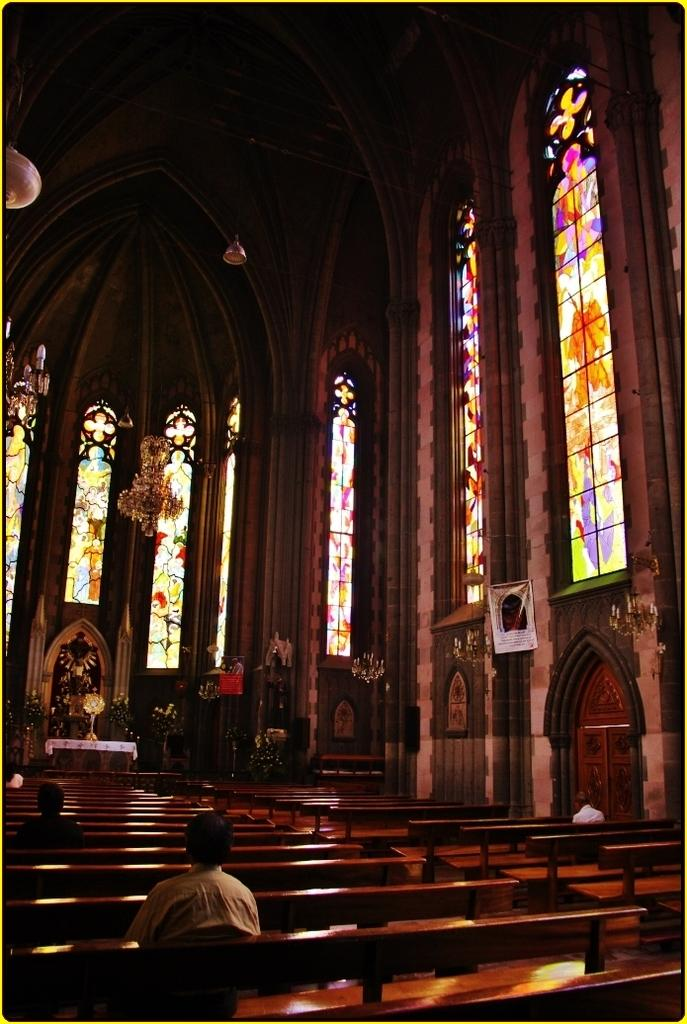What are the people in the image doing? The people in the image are sitting on benches. What other object can be seen in the image besides the people? There is a statue in the image. What type of lighting is present in the image? There are lights on the ceiling in the image. What can be seen on the windows in the image? There are designer glasses on the windows in the image. What type of sheet is covering the statue in the image? There is no sheet covering the statue in the image; the statue is visible. 